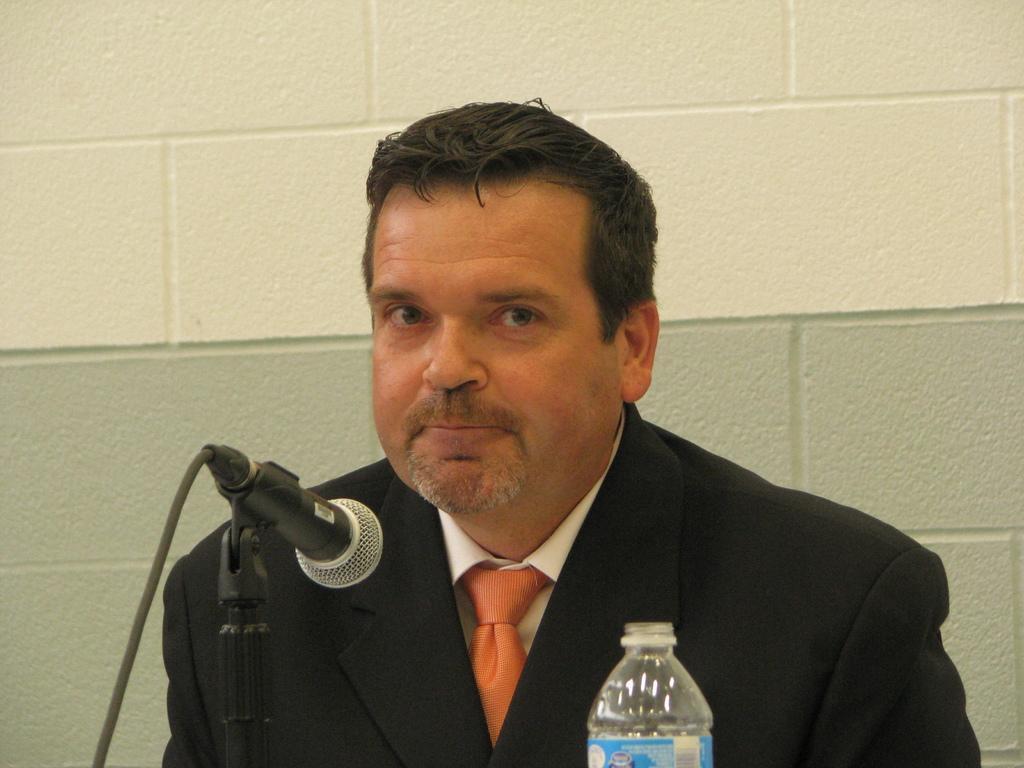Could you give a brief overview of what you see in this image? In this Image I see a man and there is a mic and a bottle in front of him. In the background i see the wall. 